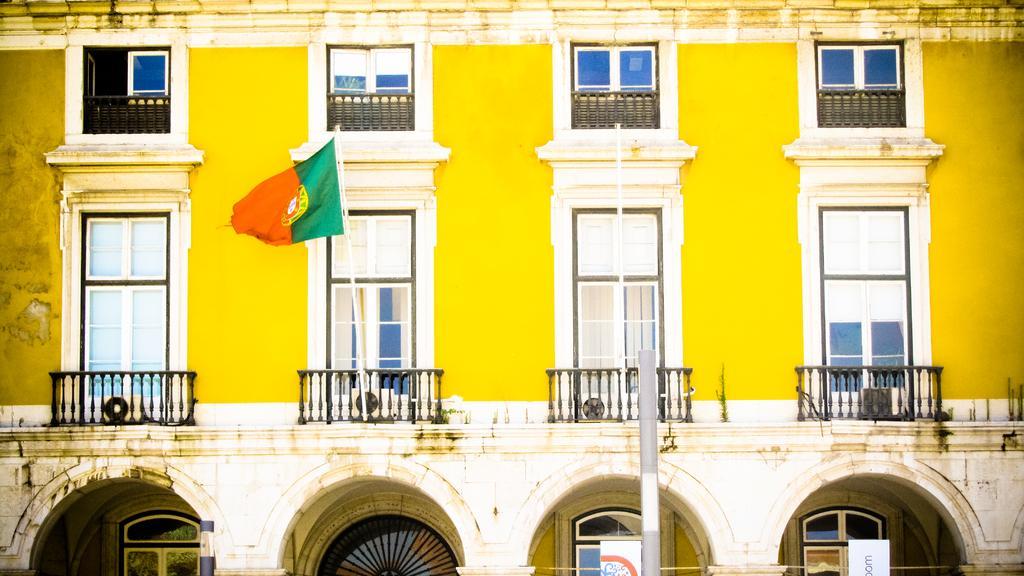In one or two sentences, can you explain what this image depicts? In this image there is a building and there is a flag, pillar and two boards with some text. 